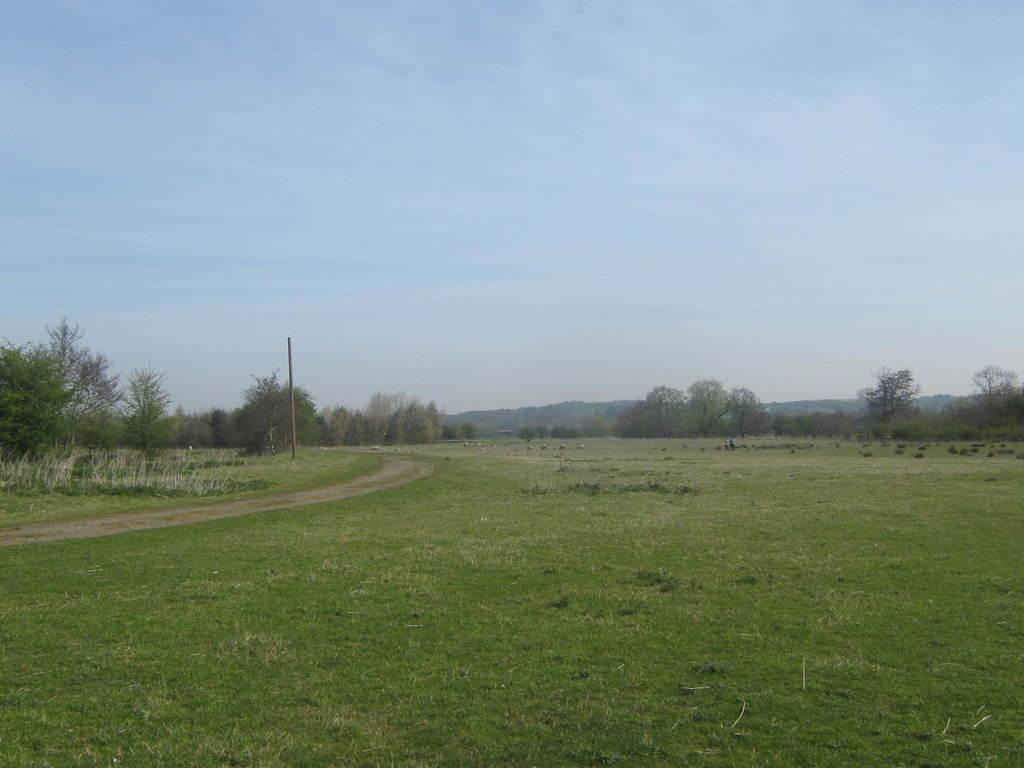What type of vegetation can be seen in the image? There is grass, plants, and trees in the image. What is the condition of the sky in the image? The sky is clear in the image. How many bikes are parked near the trees in the image? There are no bikes present in the image; it only features grass, plants, trees, and a clear sky. What company is responsible for maintaining the plants in the image? There is no information about a company responsible for maintaining the plants in the image. 